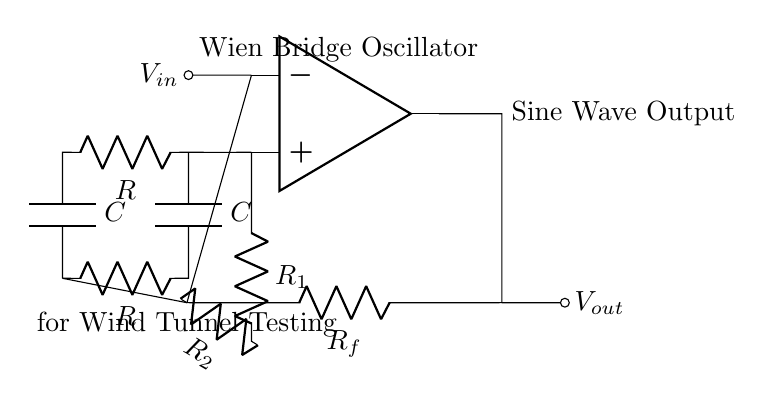What is the purpose of the Wien Bridge oscillator? The Wien Bridge oscillator is specifically designed to generate sine waves, which are essential for various testing applications including wind tunnel testing systems.
Answer: Generate sine waves What does R_f represent in the circuit? R_f represents the feedback resistor in the operational amplifier circuit, which plays a crucial role in setting the gain of the oscillator.
Answer: Feedback resistor How many resistors are used in the Wien bridge section of the circuit? There are two resistors in the Wien bridge section represented as R, as per the circuit diagram.
Answer: Two resistors What is the relationship between R_1 and R_2? R_1 and R_2 form a voltage divider that controls the gain, making their relationship crucial for stability in the oscillator output.
Answer: Gain control Which component provides phase shift in this oscillator? The capacitors (C) provide the necessary phase shift required for oscillation to occur in the Wien Bridge oscillator.
Answer: Capacitors How does the circuit ensure oscillation at a specific frequency? The values of resistors and capacitors (R and C) dictate the oscillation frequency based on the Wien bridge formula, creating a condition for consistent sine wave generation.
Answer: Frequency determination 